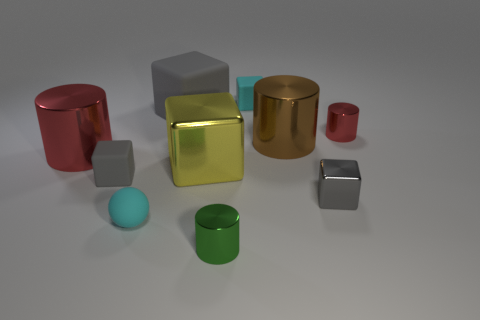Subtract all tiny matte blocks. How many blocks are left? 3 Subtract all gray cubes. How many cubes are left? 2 Subtract 5 cubes. How many cubes are left? 0 Add 3 big gray objects. How many big gray objects are left? 4 Add 5 large gray blocks. How many large gray blocks exist? 6 Subtract 0 green cubes. How many objects are left? 10 Subtract all cylinders. How many objects are left? 6 Subtract all red cylinders. Subtract all green cubes. How many cylinders are left? 2 Subtract all blue cubes. How many green cylinders are left? 1 Subtract all small matte objects. Subtract all brown things. How many objects are left? 6 